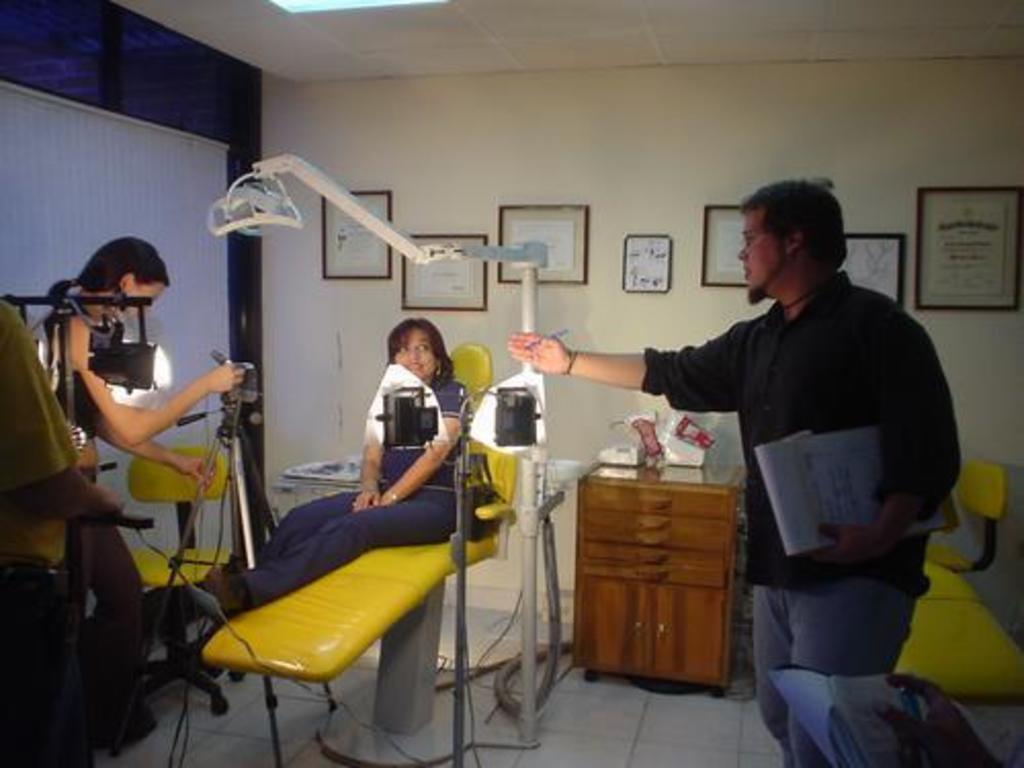How would you summarize this image in a sentence or two? In this Image I can see three people. One person is holding the papers and another person is sitting on the yellow color surface. To the left there is a machine and I can see the brown color cupboard to the side and there are some objects in it. In the back there are boards to the wall. 